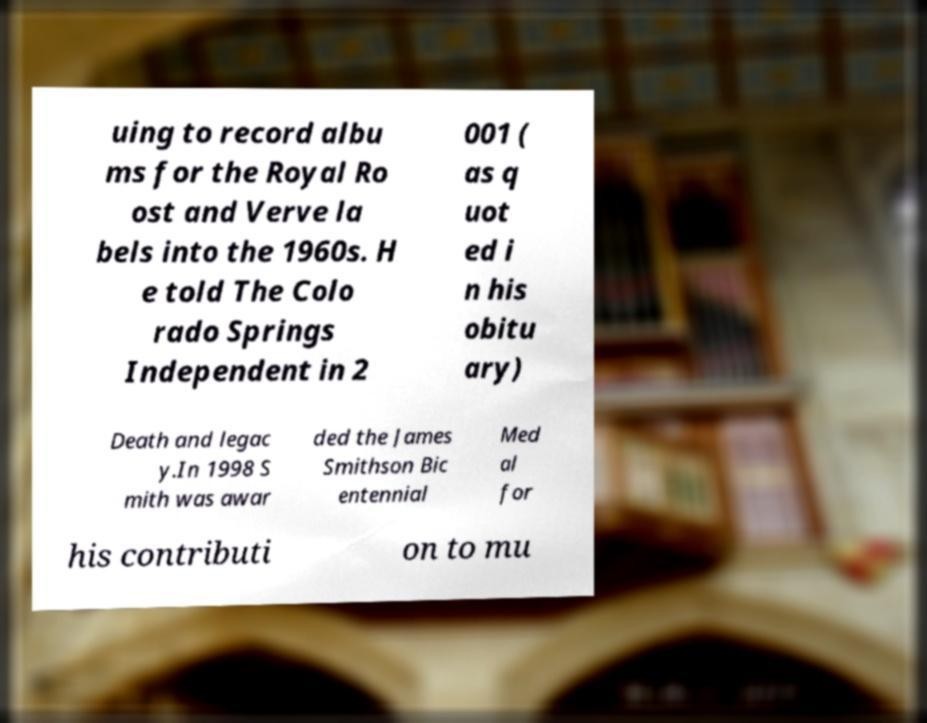Can you accurately transcribe the text from the provided image for me? uing to record albu ms for the Royal Ro ost and Verve la bels into the 1960s. H e told The Colo rado Springs Independent in 2 001 ( as q uot ed i n his obitu ary) Death and legac y.In 1998 S mith was awar ded the James Smithson Bic entennial Med al for his contributi on to mu 